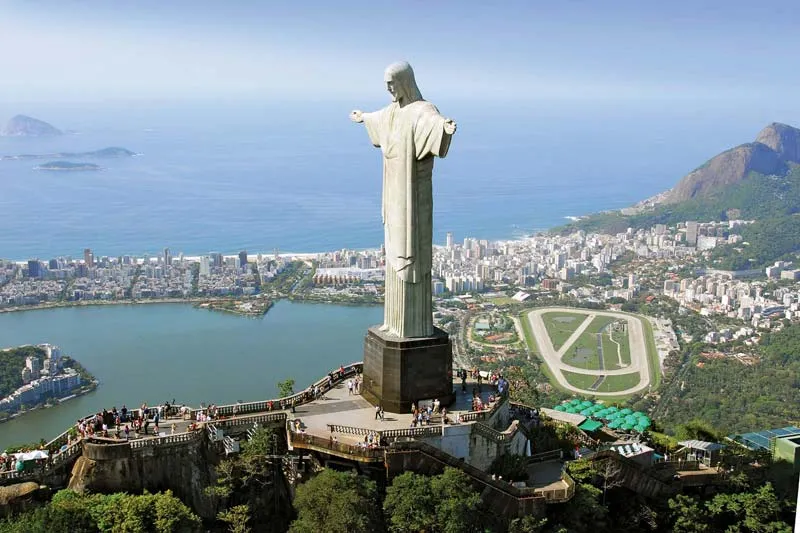How does this image illustrate the relationship between the statue and the surrounding city? The image illustrates a dynamic relationship between the Christ the Redeemer statue and Rio de Janeiro. The statue, perched atop Corcovado mountain, oversees the city, symbolizing a watchful guardian. The panoramic view shows the city's architecture and natural landscapes intertwined, depicting the harmonious coexistence of urban development and natural beauty. This positioning suggests a protective stance, with the statue interlinking cultural history and modern progression. 